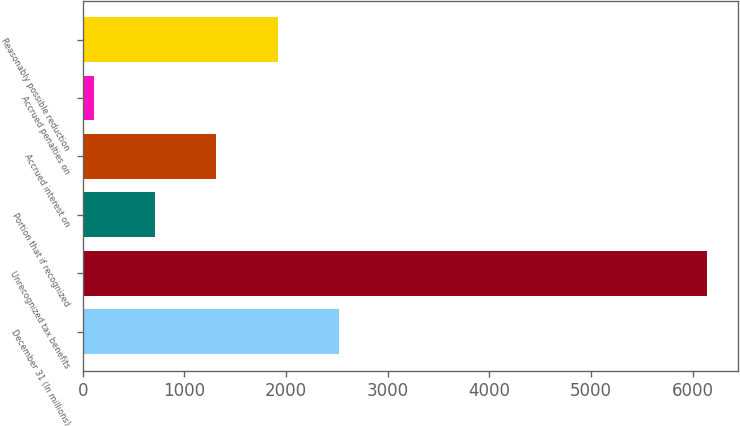Convert chart to OTSL. <chart><loc_0><loc_0><loc_500><loc_500><bar_chart><fcel>December 31 (In millions)<fcel>Unrecognized tax benefits<fcel>Portion that if recognized<fcel>Accrued interest on<fcel>Accrued penalties on<fcel>Reasonably possible reduction<nl><fcel>2521<fcel>6139<fcel>712<fcel>1315<fcel>109<fcel>1918<nl></chart> 